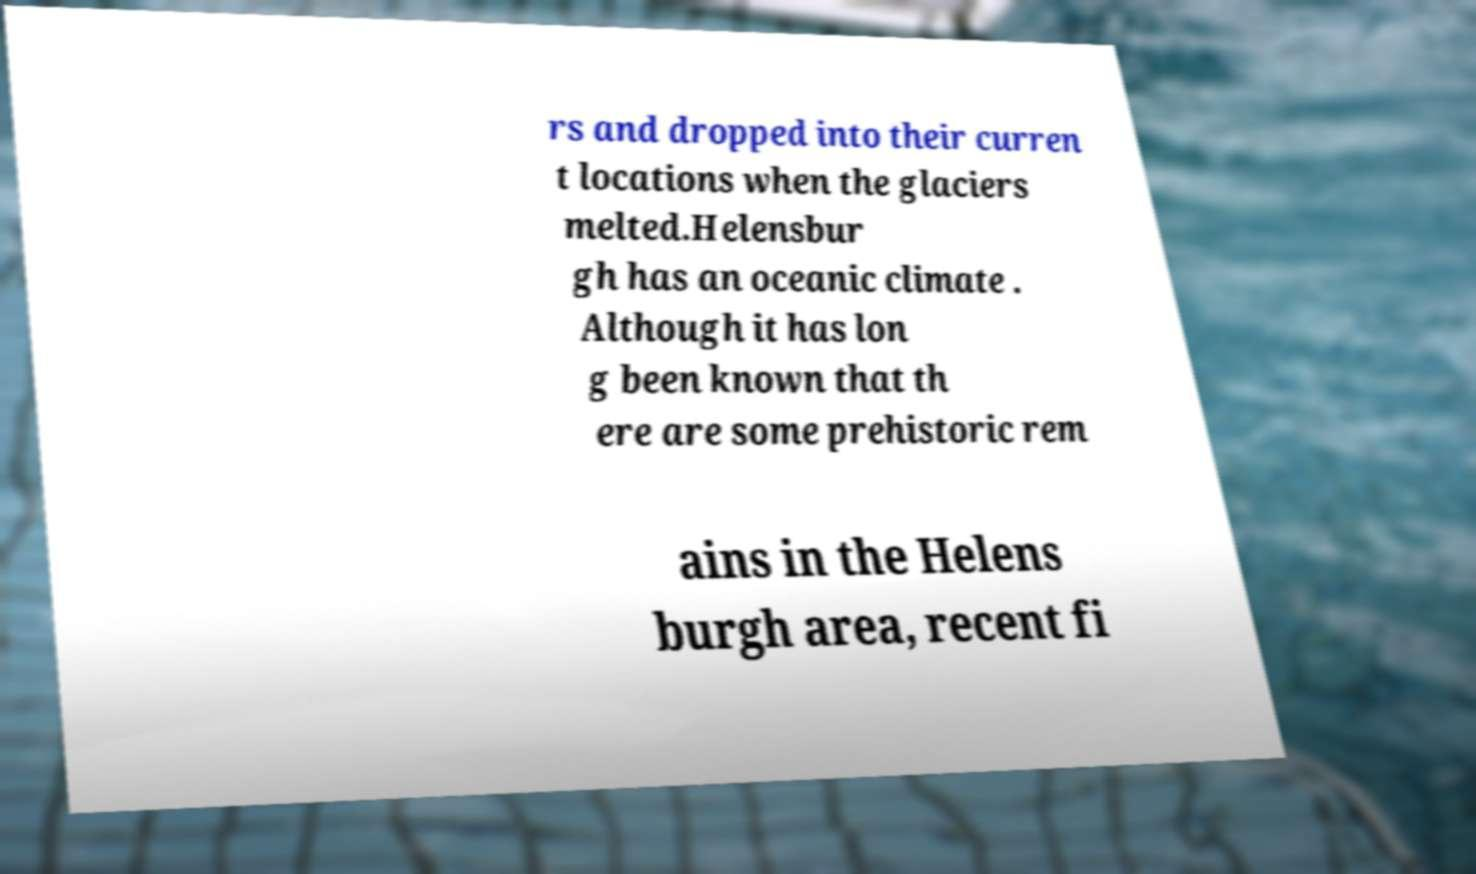Please read and relay the text visible in this image. What does it say? rs and dropped into their curren t locations when the glaciers melted.Helensbur gh has an oceanic climate . Although it has lon g been known that th ere are some prehistoric rem ains in the Helens burgh area, recent fi 